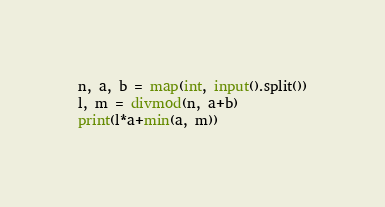<code> <loc_0><loc_0><loc_500><loc_500><_Python_>n, a, b = map(int, input().split())
l, m = divmod(n, a+b)
print(l*a+min(a, m))
</code> 